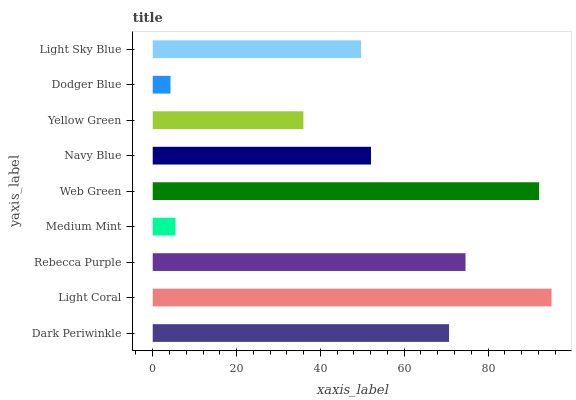Is Dodger Blue the minimum?
Answer yes or no. Yes. Is Light Coral the maximum?
Answer yes or no. Yes. Is Rebecca Purple the minimum?
Answer yes or no. No. Is Rebecca Purple the maximum?
Answer yes or no. No. Is Light Coral greater than Rebecca Purple?
Answer yes or no. Yes. Is Rebecca Purple less than Light Coral?
Answer yes or no. Yes. Is Rebecca Purple greater than Light Coral?
Answer yes or no. No. Is Light Coral less than Rebecca Purple?
Answer yes or no. No. Is Navy Blue the high median?
Answer yes or no. Yes. Is Navy Blue the low median?
Answer yes or no. Yes. Is Dark Periwinkle the high median?
Answer yes or no. No. Is Light Coral the low median?
Answer yes or no. No. 